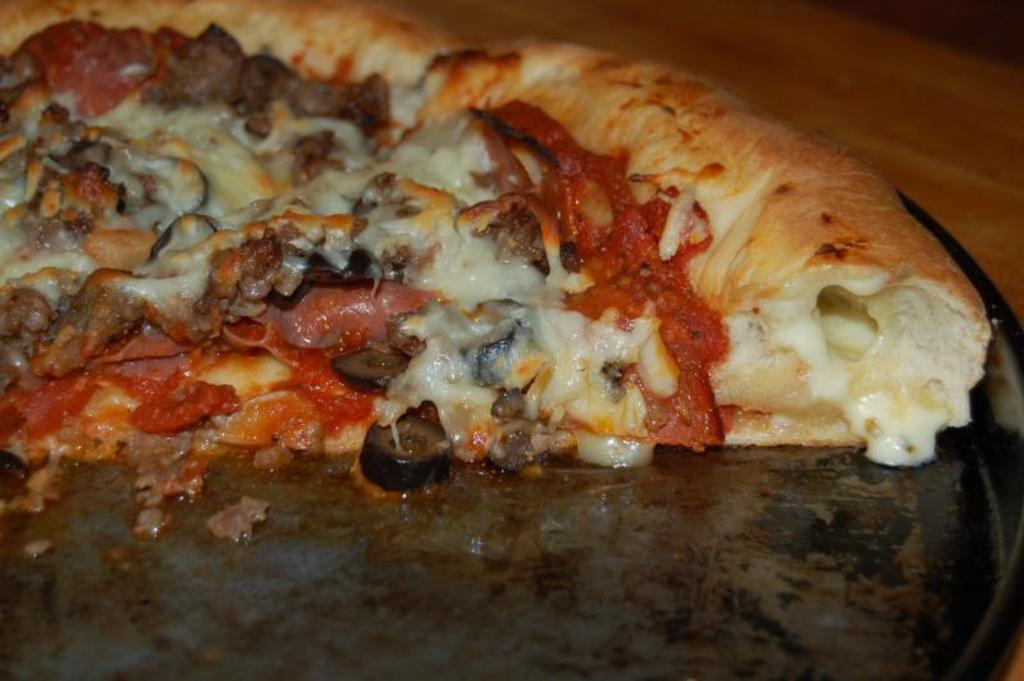What type of food is on the serving plate in the image? There is pizza on a serving plate in the image. What type of twist can be seen in the image? There is no twist present in the image; it features a serving plate with pizza on it. 